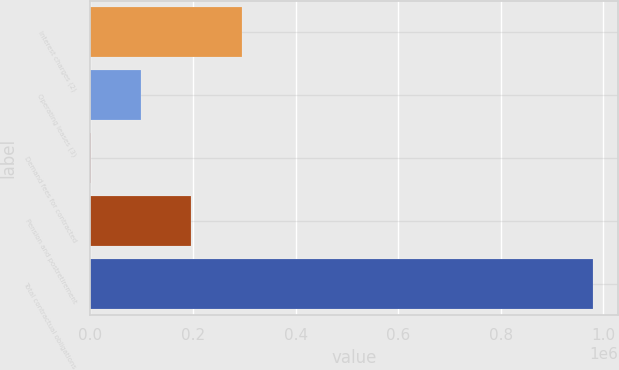<chart> <loc_0><loc_0><loc_500><loc_500><bar_chart><fcel>Interest charges (2)<fcel>Operating leases (3)<fcel>Demand fees for contracted<fcel>Pension and postretirement<fcel>Total contractual obligations<nl><fcel>294725<fcel>99021.6<fcel>1170<fcel>196873<fcel>979686<nl></chart> 